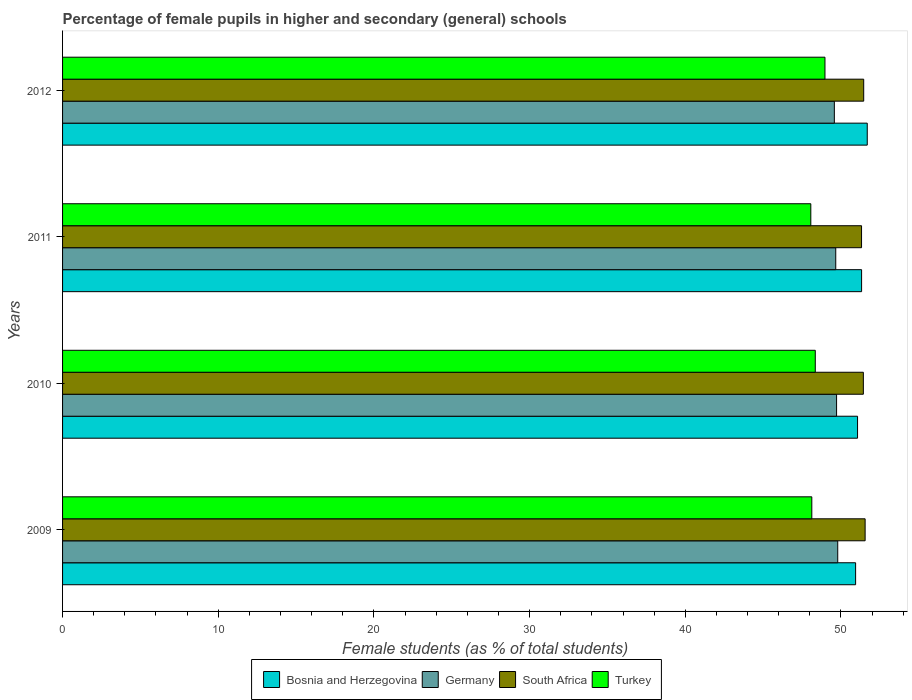How many different coloured bars are there?
Give a very brief answer. 4. Are the number of bars per tick equal to the number of legend labels?
Offer a terse response. Yes. How many bars are there on the 3rd tick from the bottom?
Your answer should be compact. 4. What is the percentage of female pupils in higher and secondary schools in Germany in 2010?
Offer a terse response. 49.72. Across all years, what is the maximum percentage of female pupils in higher and secondary schools in Bosnia and Herzegovina?
Give a very brief answer. 51.69. Across all years, what is the minimum percentage of female pupils in higher and secondary schools in Germany?
Make the answer very short. 49.57. In which year was the percentage of female pupils in higher and secondary schools in Turkey minimum?
Give a very brief answer. 2011. What is the total percentage of female pupils in higher and secondary schools in Germany in the graph?
Your answer should be very brief. 198.74. What is the difference between the percentage of female pupils in higher and secondary schools in Germany in 2009 and that in 2010?
Keep it short and to the point. 0.07. What is the difference between the percentage of female pupils in higher and secondary schools in Bosnia and Herzegovina in 2009 and the percentage of female pupils in higher and secondary schools in South Africa in 2011?
Ensure brevity in your answer.  -0.38. What is the average percentage of female pupils in higher and secondary schools in Bosnia and Herzegovina per year?
Your response must be concise. 51.25. In the year 2011, what is the difference between the percentage of female pupils in higher and secondary schools in Turkey and percentage of female pupils in higher and secondary schools in Germany?
Your answer should be very brief. -1.6. In how many years, is the percentage of female pupils in higher and secondary schools in Germany greater than 12 %?
Offer a very short reply. 4. What is the ratio of the percentage of female pupils in higher and secondary schools in South Africa in 2010 to that in 2012?
Give a very brief answer. 1. Is the percentage of female pupils in higher and secondary schools in Bosnia and Herzegovina in 2009 less than that in 2011?
Provide a short and direct response. Yes. What is the difference between the highest and the second highest percentage of female pupils in higher and secondary schools in South Africa?
Keep it short and to the point. 0.09. What is the difference between the highest and the lowest percentage of female pupils in higher and secondary schools in Turkey?
Offer a terse response. 0.91. Is the sum of the percentage of female pupils in higher and secondary schools in South Africa in 2009 and 2012 greater than the maximum percentage of female pupils in higher and secondary schools in Germany across all years?
Offer a terse response. Yes. What does the 1st bar from the bottom in 2012 represents?
Your answer should be very brief. Bosnia and Herzegovina. Is it the case that in every year, the sum of the percentage of female pupils in higher and secondary schools in Germany and percentage of female pupils in higher and secondary schools in Turkey is greater than the percentage of female pupils in higher and secondary schools in Bosnia and Herzegovina?
Your response must be concise. Yes. What is the difference between two consecutive major ticks on the X-axis?
Provide a succinct answer. 10. Does the graph contain any zero values?
Provide a short and direct response. No. Does the graph contain grids?
Provide a succinct answer. No. Where does the legend appear in the graph?
Keep it short and to the point. Bottom center. How are the legend labels stacked?
Your response must be concise. Horizontal. What is the title of the graph?
Offer a terse response. Percentage of female pupils in higher and secondary (general) schools. What is the label or title of the X-axis?
Offer a very short reply. Female students (as % of total students). What is the label or title of the Y-axis?
Offer a very short reply. Years. What is the Female students (as % of total students) of Bosnia and Herzegovina in 2009?
Provide a short and direct response. 50.94. What is the Female students (as % of total students) of Germany in 2009?
Your response must be concise. 49.79. What is the Female students (as % of total students) in South Africa in 2009?
Make the answer very short. 51.55. What is the Female students (as % of total students) of Turkey in 2009?
Give a very brief answer. 48.13. What is the Female students (as % of total students) in Bosnia and Herzegovina in 2010?
Keep it short and to the point. 51.06. What is the Female students (as % of total students) in Germany in 2010?
Offer a terse response. 49.72. What is the Female students (as % of total students) of South Africa in 2010?
Ensure brevity in your answer.  51.44. What is the Female students (as % of total students) of Turkey in 2010?
Offer a very short reply. 48.35. What is the Female students (as % of total students) in Bosnia and Herzegovina in 2011?
Offer a terse response. 51.32. What is the Female students (as % of total students) in Germany in 2011?
Make the answer very short. 49.66. What is the Female students (as % of total students) in South Africa in 2011?
Keep it short and to the point. 51.32. What is the Female students (as % of total students) of Turkey in 2011?
Provide a succinct answer. 48.06. What is the Female students (as % of total students) in Bosnia and Herzegovina in 2012?
Your answer should be compact. 51.69. What is the Female students (as % of total students) in Germany in 2012?
Provide a short and direct response. 49.57. What is the Female students (as % of total students) of South Africa in 2012?
Make the answer very short. 51.46. What is the Female students (as % of total students) of Turkey in 2012?
Ensure brevity in your answer.  48.97. Across all years, what is the maximum Female students (as % of total students) of Bosnia and Herzegovina?
Give a very brief answer. 51.69. Across all years, what is the maximum Female students (as % of total students) of Germany?
Make the answer very short. 49.79. Across all years, what is the maximum Female students (as % of total students) in South Africa?
Your answer should be very brief. 51.55. Across all years, what is the maximum Female students (as % of total students) of Turkey?
Give a very brief answer. 48.97. Across all years, what is the minimum Female students (as % of total students) of Bosnia and Herzegovina?
Ensure brevity in your answer.  50.94. Across all years, what is the minimum Female students (as % of total students) in Germany?
Keep it short and to the point. 49.57. Across all years, what is the minimum Female students (as % of total students) in South Africa?
Your answer should be compact. 51.32. Across all years, what is the minimum Female students (as % of total students) in Turkey?
Offer a terse response. 48.06. What is the total Female students (as % of total students) of Bosnia and Herzegovina in the graph?
Provide a succinct answer. 205.01. What is the total Female students (as % of total students) in Germany in the graph?
Provide a short and direct response. 198.75. What is the total Female students (as % of total students) of South Africa in the graph?
Your answer should be compact. 205.77. What is the total Female students (as % of total students) in Turkey in the graph?
Ensure brevity in your answer.  193.51. What is the difference between the Female students (as % of total students) of Bosnia and Herzegovina in 2009 and that in 2010?
Your answer should be very brief. -0.12. What is the difference between the Female students (as % of total students) of Germany in 2009 and that in 2010?
Offer a terse response. 0.07. What is the difference between the Female students (as % of total students) in South Africa in 2009 and that in 2010?
Give a very brief answer. 0.11. What is the difference between the Female students (as % of total students) of Turkey in 2009 and that in 2010?
Ensure brevity in your answer.  -0.22. What is the difference between the Female students (as % of total students) of Bosnia and Herzegovina in 2009 and that in 2011?
Give a very brief answer. -0.38. What is the difference between the Female students (as % of total students) in Germany in 2009 and that in 2011?
Offer a very short reply. 0.13. What is the difference between the Female students (as % of total students) of South Africa in 2009 and that in 2011?
Your answer should be compact. 0.23. What is the difference between the Female students (as % of total students) in Turkey in 2009 and that in 2011?
Provide a short and direct response. 0.06. What is the difference between the Female students (as % of total students) of Bosnia and Herzegovina in 2009 and that in 2012?
Make the answer very short. -0.75. What is the difference between the Female students (as % of total students) in Germany in 2009 and that in 2012?
Your answer should be very brief. 0.22. What is the difference between the Female students (as % of total students) in South Africa in 2009 and that in 2012?
Your answer should be very brief. 0.09. What is the difference between the Female students (as % of total students) of Turkey in 2009 and that in 2012?
Your answer should be very brief. -0.84. What is the difference between the Female students (as % of total students) of Bosnia and Herzegovina in 2010 and that in 2011?
Your answer should be compact. -0.26. What is the difference between the Female students (as % of total students) in Germany in 2010 and that in 2011?
Provide a short and direct response. 0.05. What is the difference between the Female students (as % of total students) in South Africa in 2010 and that in 2011?
Make the answer very short. 0.12. What is the difference between the Female students (as % of total students) in Turkey in 2010 and that in 2011?
Your response must be concise. 0.29. What is the difference between the Female students (as % of total students) in Bosnia and Herzegovina in 2010 and that in 2012?
Keep it short and to the point. -0.62. What is the difference between the Female students (as % of total students) in Germany in 2010 and that in 2012?
Give a very brief answer. 0.14. What is the difference between the Female students (as % of total students) in South Africa in 2010 and that in 2012?
Your answer should be compact. -0.02. What is the difference between the Female students (as % of total students) in Turkey in 2010 and that in 2012?
Give a very brief answer. -0.62. What is the difference between the Female students (as % of total students) in Bosnia and Herzegovina in 2011 and that in 2012?
Your response must be concise. -0.36. What is the difference between the Female students (as % of total students) of Germany in 2011 and that in 2012?
Provide a succinct answer. 0.09. What is the difference between the Female students (as % of total students) of South Africa in 2011 and that in 2012?
Keep it short and to the point. -0.14. What is the difference between the Female students (as % of total students) of Turkey in 2011 and that in 2012?
Ensure brevity in your answer.  -0.91. What is the difference between the Female students (as % of total students) of Bosnia and Herzegovina in 2009 and the Female students (as % of total students) of Germany in 2010?
Provide a succinct answer. 1.22. What is the difference between the Female students (as % of total students) in Bosnia and Herzegovina in 2009 and the Female students (as % of total students) in South Africa in 2010?
Provide a succinct answer. -0.5. What is the difference between the Female students (as % of total students) of Bosnia and Herzegovina in 2009 and the Female students (as % of total students) of Turkey in 2010?
Provide a succinct answer. 2.59. What is the difference between the Female students (as % of total students) in Germany in 2009 and the Female students (as % of total students) in South Africa in 2010?
Your response must be concise. -1.65. What is the difference between the Female students (as % of total students) in Germany in 2009 and the Female students (as % of total students) in Turkey in 2010?
Make the answer very short. 1.44. What is the difference between the Female students (as % of total students) in South Africa in 2009 and the Female students (as % of total students) in Turkey in 2010?
Your response must be concise. 3.2. What is the difference between the Female students (as % of total students) of Bosnia and Herzegovina in 2009 and the Female students (as % of total students) of Germany in 2011?
Offer a very short reply. 1.28. What is the difference between the Female students (as % of total students) of Bosnia and Herzegovina in 2009 and the Female students (as % of total students) of South Africa in 2011?
Your response must be concise. -0.38. What is the difference between the Female students (as % of total students) in Bosnia and Herzegovina in 2009 and the Female students (as % of total students) in Turkey in 2011?
Your answer should be very brief. 2.88. What is the difference between the Female students (as % of total students) in Germany in 2009 and the Female students (as % of total students) in South Africa in 2011?
Make the answer very short. -1.53. What is the difference between the Female students (as % of total students) in Germany in 2009 and the Female students (as % of total students) in Turkey in 2011?
Give a very brief answer. 1.73. What is the difference between the Female students (as % of total students) of South Africa in 2009 and the Female students (as % of total students) of Turkey in 2011?
Offer a terse response. 3.49. What is the difference between the Female students (as % of total students) in Bosnia and Herzegovina in 2009 and the Female students (as % of total students) in Germany in 2012?
Offer a very short reply. 1.37. What is the difference between the Female students (as % of total students) of Bosnia and Herzegovina in 2009 and the Female students (as % of total students) of South Africa in 2012?
Make the answer very short. -0.52. What is the difference between the Female students (as % of total students) in Bosnia and Herzegovina in 2009 and the Female students (as % of total students) in Turkey in 2012?
Give a very brief answer. 1.97. What is the difference between the Female students (as % of total students) in Germany in 2009 and the Female students (as % of total students) in South Africa in 2012?
Your answer should be compact. -1.67. What is the difference between the Female students (as % of total students) of Germany in 2009 and the Female students (as % of total students) of Turkey in 2012?
Ensure brevity in your answer.  0.82. What is the difference between the Female students (as % of total students) in South Africa in 2009 and the Female students (as % of total students) in Turkey in 2012?
Give a very brief answer. 2.58. What is the difference between the Female students (as % of total students) in Bosnia and Herzegovina in 2010 and the Female students (as % of total students) in Germany in 2011?
Your response must be concise. 1.4. What is the difference between the Female students (as % of total students) of Bosnia and Herzegovina in 2010 and the Female students (as % of total students) of South Africa in 2011?
Make the answer very short. -0.26. What is the difference between the Female students (as % of total students) in Bosnia and Herzegovina in 2010 and the Female students (as % of total students) in Turkey in 2011?
Provide a short and direct response. 3. What is the difference between the Female students (as % of total students) of Germany in 2010 and the Female students (as % of total students) of South Africa in 2011?
Your response must be concise. -1.6. What is the difference between the Female students (as % of total students) of Germany in 2010 and the Female students (as % of total students) of Turkey in 2011?
Provide a succinct answer. 1.65. What is the difference between the Female students (as % of total students) in South Africa in 2010 and the Female students (as % of total students) in Turkey in 2011?
Provide a short and direct response. 3.37. What is the difference between the Female students (as % of total students) of Bosnia and Herzegovina in 2010 and the Female students (as % of total students) of Germany in 2012?
Make the answer very short. 1.49. What is the difference between the Female students (as % of total students) in Bosnia and Herzegovina in 2010 and the Female students (as % of total students) in South Africa in 2012?
Provide a short and direct response. -0.4. What is the difference between the Female students (as % of total students) in Bosnia and Herzegovina in 2010 and the Female students (as % of total students) in Turkey in 2012?
Give a very brief answer. 2.09. What is the difference between the Female students (as % of total students) in Germany in 2010 and the Female students (as % of total students) in South Africa in 2012?
Offer a terse response. -1.74. What is the difference between the Female students (as % of total students) of Germany in 2010 and the Female students (as % of total students) of Turkey in 2012?
Give a very brief answer. 0.75. What is the difference between the Female students (as % of total students) in South Africa in 2010 and the Female students (as % of total students) in Turkey in 2012?
Give a very brief answer. 2.47. What is the difference between the Female students (as % of total students) of Bosnia and Herzegovina in 2011 and the Female students (as % of total students) of Germany in 2012?
Ensure brevity in your answer.  1.75. What is the difference between the Female students (as % of total students) in Bosnia and Herzegovina in 2011 and the Female students (as % of total students) in South Africa in 2012?
Keep it short and to the point. -0.14. What is the difference between the Female students (as % of total students) of Bosnia and Herzegovina in 2011 and the Female students (as % of total students) of Turkey in 2012?
Give a very brief answer. 2.35. What is the difference between the Female students (as % of total students) of Germany in 2011 and the Female students (as % of total students) of South Africa in 2012?
Offer a very short reply. -1.8. What is the difference between the Female students (as % of total students) of Germany in 2011 and the Female students (as % of total students) of Turkey in 2012?
Provide a short and direct response. 0.69. What is the difference between the Female students (as % of total students) of South Africa in 2011 and the Female students (as % of total students) of Turkey in 2012?
Provide a short and direct response. 2.35. What is the average Female students (as % of total students) in Bosnia and Herzegovina per year?
Keep it short and to the point. 51.25. What is the average Female students (as % of total students) of Germany per year?
Offer a very short reply. 49.69. What is the average Female students (as % of total students) in South Africa per year?
Make the answer very short. 51.44. What is the average Female students (as % of total students) in Turkey per year?
Give a very brief answer. 48.38. In the year 2009, what is the difference between the Female students (as % of total students) in Bosnia and Herzegovina and Female students (as % of total students) in Germany?
Make the answer very short. 1.15. In the year 2009, what is the difference between the Female students (as % of total students) in Bosnia and Herzegovina and Female students (as % of total students) in South Africa?
Your response must be concise. -0.61. In the year 2009, what is the difference between the Female students (as % of total students) of Bosnia and Herzegovina and Female students (as % of total students) of Turkey?
Keep it short and to the point. 2.81. In the year 2009, what is the difference between the Female students (as % of total students) of Germany and Female students (as % of total students) of South Africa?
Your response must be concise. -1.76. In the year 2009, what is the difference between the Female students (as % of total students) of Germany and Female students (as % of total students) of Turkey?
Your answer should be very brief. 1.66. In the year 2009, what is the difference between the Female students (as % of total students) in South Africa and Female students (as % of total students) in Turkey?
Your response must be concise. 3.42. In the year 2010, what is the difference between the Female students (as % of total students) in Bosnia and Herzegovina and Female students (as % of total students) in Germany?
Your response must be concise. 1.35. In the year 2010, what is the difference between the Female students (as % of total students) in Bosnia and Herzegovina and Female students (as % of total students) in South Africa?
Your response must be concise. -0.37. In the year 2010, what is the difference between the Female students (as % of total students) in Bosnia and Herzegovina and Female students (as % of total students) in Turkey?
Provide a short and direct response. 2.71. In the year 2010, what is the difference between the Female students (as % of total students) in Germany and Female students (as % of total students) in South Africa?
Ensure brevity in your answer.  -1.72. In the year 2010, what is the difference between the Female students (as % of total students) of Germany and Female students (as % of total students) of Turkey?
Your response must be concise. 1.37. In the year 2010, what is the difference between the Female students (as % of total students) of South Africa and Female students (as % of total students) of Turkey?
Your answer should be very brief. 3.09. In the year 2011, what is the difference between the Female students (as % of total students) of Bosnia and Herzegovina and Female students (as % of total students) of Germany?
Offer a terse response. 1.66. In the year 2011, what is the difference between the Female students (as % of total students) of Bosnia and Herzegovina and Female students (as % of total students) of South Africa?
Give a very brief answer. 0. In the year 2011, what is the difference between the Female students (as % of total students) in Bosnia and Herzegovina and Female students (as % of total students) in Turkey?
Ensure brevity in your answer.  3.26. In the year 2011, what is the difference between the Female students (as % of total students) in Germany and Female students (as % of total students) in South Africa?
Your response must be concise. -1.66. In the year 2011, what is the difference between the Female students (as % of total students) of Germany and Female students (as % of total students) of Turkey?
Your response must be concise. 1.6. In the year 2011, what is the difference between the Female students (as % of total students) of South Africa and Female students (as % of total students) of Turkey?
Your response must be concise. 3.26. In the year 2012, what is the difference between the Female students (as % of total students) of Bosnia and Herzegovina and Female students (as % of total students) of Germany?
Ensure brevity in your answer.  2.11. In the year 2012, what is the difference between the Female students (as % of total students) of Bosnia and Herzegovina and Female students (as % of total students) of South Africa?
Your response must be concise. 0.23. In the year 2012, what is the difference between the Female students (as % of total students) of Bosnia and Herzegovina and Female students (as % of total students) of Turkey?
Provide a succinct answer. 2.72. In the year 2012, what is the difference between the Female students (as % of total students) in Germany and Female students (as % of total students) in South Africa?
Keep it short and to the point. -1.89. In the year 2012, what is the difference between the Female students (as % of total students) of Germany and Female students (as % of total students) of Turkey?
Your answer should be compact. 0.6. In the year 2012, what is the difference between the Female students (as % of total students) of South Africa and Female students (as % of total students) of Turkey?
Provide a short and direct response. 2.49. What is the ratio of the Female students (as % of total students) of Bosnia and Herzegovina in 2009 to that in 2010?
Keep it short and to the point. 1. What is the ratio of the Female students (as % of total students) in Germany in 2009 to that in 2010?
Provide a short and direct response. 1. What is the ratio of the Female students (as % of total students) in Turkey in 2009 to that in 2010?
Your answer should be compact. 1. What is the ratio of the Female students (as % of total students) of Bosnia and Herzegovina in 2009 to that in 2012?
Provide a short and direct response. 0.99. What is the ratio of the Female students (as % of total students) in South Africa in 2009 to that in 2012?
Your answer should be compact. 1. What is the ratio of the Female students (as % of total students) in Turkey in 2009 to that in 2012?
Your answer should be compact. 0.98. What is the ratio of the Female students (as % of total students) of Bosnia and Herzegovina in 2010 to that in 2011?
Offer a very short reply. 0.99. What is the ratio of the Female students (as % of total students) in Germany in 2010 to that in 2011?
Your answer should be compact. 1. What is the ratio of the Female students (as % of total students) of Turkey in 2010 to that in 2011?
Provide a succinct answer. 1.01. What is the ratio of the Female students (as % of total students) in Bosnia and Herzegovina in 2010 to that in 2012?
Make the answer very short. 0.99. What is the ratio of the Female students (as % of total students) of Turkey in 2010 to that in 2012?
Offer a terse response. 0.99. What is the ratio of the Female students (as % of total students) of Bosnia and Herzegovina in 2011 to that in 2012?
Make the answer very short. 0.99. What is the ratio of the Female students (as % of total students) in Germany in 2011 to that in 2012?
Provide a succinct answer. 1. What is the ratio of the Female students (as % of total students) of South Africa in 2011 to that in 2012?
Provide a succinct answer. 1. What is the ratio of the Female students (as % of total students) in Turkey in 2011 to that in 2012?
Keep it short and to the point. 0.98. What is the difference between the highest and the second highest Female students (as % of total students) of Bosnia and Herzegovina?
Give a very brief answer. 0.36. What is the difference between the highest and the second highest Female students (as % of total students) of Germany?
Offer a terse response. 0.07. What is the difference between the highest and the second highest Female students (as % of total students) in South Africa?
Give a very brief answer. 0.09. What is the difference between the highest and the second highest Female students (as % of total students) in Turkey?
Keep it short and to the point. 0.62. What is the difference between the highest and the lowest Female students (as % of total students) in Bosnia and Herzegovina?
Your answer should be compact. 0.75. What is the difference between the highest and the lowest Female students (as % of total students) in Germany?
Give a very brief answer. 0.22. What is the difference between the highest and the lowest Female students (as % of total students) in South Africa?
Ensure brevity in your answer.  0.23. What is the difference between the highest and the lowest Female students (as % of total students) of Turkey?
Provide a succinct answer. 0.91. 